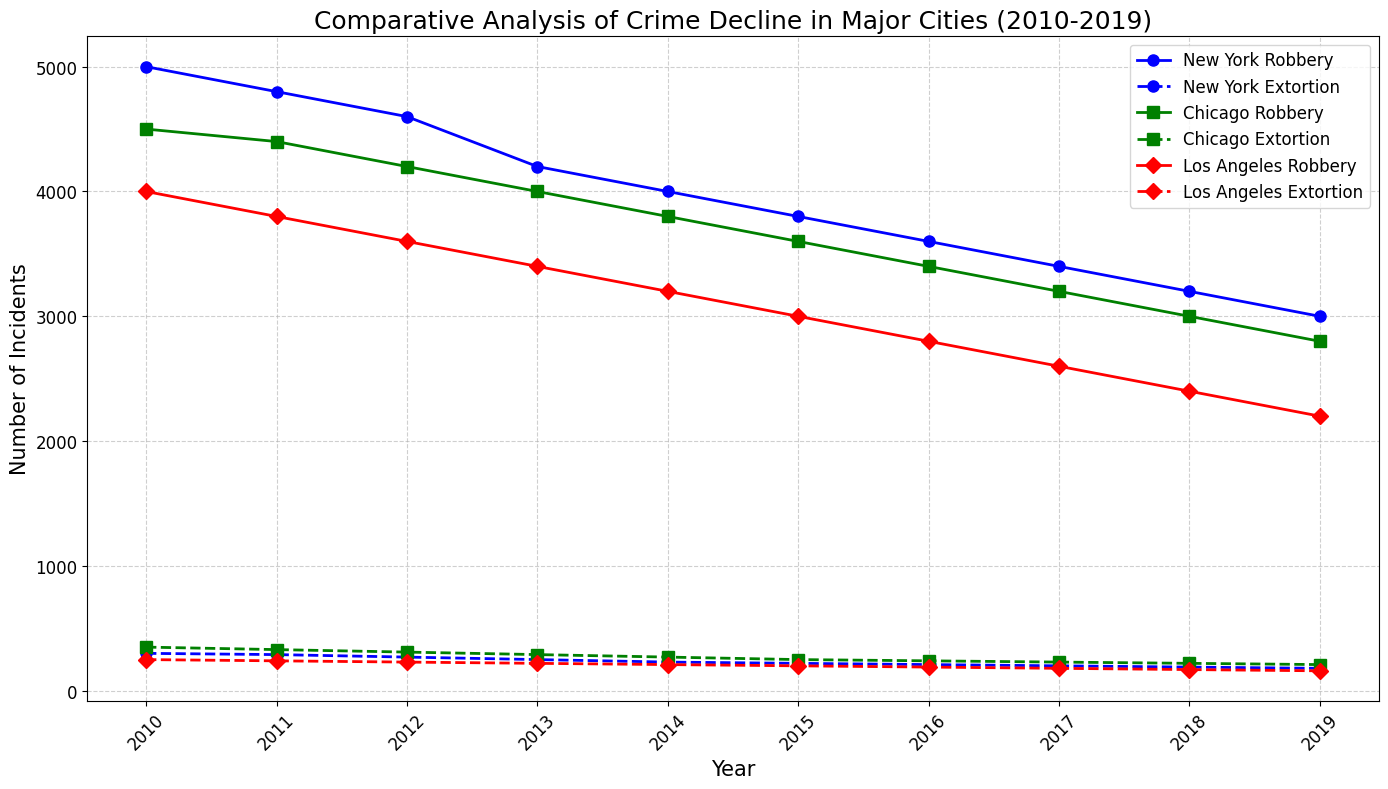What city experienced the largest decrease in robbery incidents from 2010 to 2019? Identify the number of robbery incidents in 2010 and 2019 for each city. Subtract the 2019 number from the 2010 number for each city. New York: 5000 - 3000 = 2000, Chicago: 4500 - 2800 = 1700, Los Angeles: 4000 - 2200 = 1800. Therefore, New York experienced the largest decrease.
Answer: New York Which city had the highest number of extortion incidents in 2010? Compare the number of extortion incidents in 2010 across the three cities: New York (300), Chicago (350), Los Angeles (250). Chicago had the highest number in 2010.
Answer: Chicago In which year did Chicago's robbery incidents drop below 3000? Identify the trend of robbery incidents in Chicago from 2010 to 2019. Chicago's robbery incidents dropped below 3000 in 2018.
Answer: 2018 How does the trend of extortion incidents in Los Angeles compare to the trend in New York? Examine the plots for extortion incidents for Los Angeles (red dashed line) and New York (blue dashed line). Both cities show a downward trend, but Los Angeles started higher in 2010 and ended lower in 2019 compared to New York.
Answer: Both cities show a downward trend, but Los Angeles started higher and ended lower What is the overall percentage decrease in extortion incidents for New York from 2010 to 2019? Calculate the percentage decrease from 300 incidents in 2010 to 180 in 2019: ((300 - 180) / 300) * 100. This equals (120 / 300) * 100 = 40%.
Answer: 40% How do the robbery trends in New York and Chicago compare over the decade? Examine the plots for robbery incidents in New York (blue solid line) and Chicago (green solid line). Both cities show a consistent downward trend, but New York's decline is sharper from a higher starting point to a lower end point compared to Chicago.
Answer: Both show a consistent downward trend; New York's decline is sharper Which city's extortion incidents decreased the most in absolute numbers over the decade? Compare the decrease from 2010 to 2019 for each city: New York: 300 - 180 = 120, Chicago: 350 - 210 = 140, Los Angeles: 250 - 160 = 90. Chicago has the highest absolute decrease.
Answer: Chicago By how much did robbery incidents decrease in Los Angeles from 2012 to 2015? Subtract the number of robbery incidents in 2015 (3000) from 2012 (3600). 3600 - 3000 = 600.
Answer: 600 What year did Los Angeles witness the biggest single-year drop in extortion incidents? Compare the annual decreases in extortion incidents for Los Angeles. The largest drop occurred between 2010 (250) and 2011 (240).
Answer: 2011 